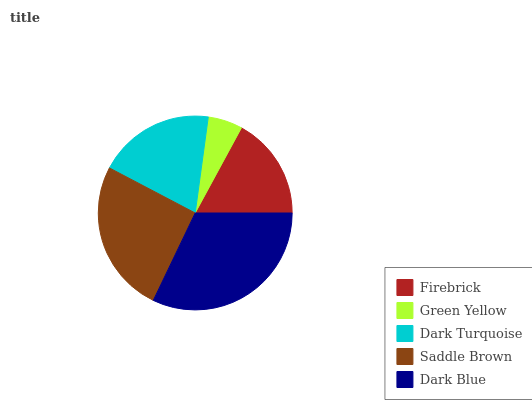Is Green Yellow the minimum?
Answer yes or no. Yes. Is Dark Blue the maximum?
Answer yes or no. Yes. Is Dark Turquoise the minimum?
Answer yes or no. No. Is Dark Turquoise the maximum?
Answer yes or no. No. Is Dark Turquoise greater than Green Yellow?
Answer yes or no. Yes. Is Green Yellow less than Dark Turquoise?
Answer yes or no. Yes. Is Green Yellow greater than Dark Turquoise?
Answer yes or no. No. Is Dark Turquoise less than Green Yellow?
Answer yes or no. No. Is Dark Turquoise the high median?
Answer yes or no. Yes. Is Dark Turquoise the low median?
Answer yes or no. Yes. Is Saddle Brown the high median?
Answer yes or no. No. Is Dark Blue the low median?
Answer yes or no. No. 